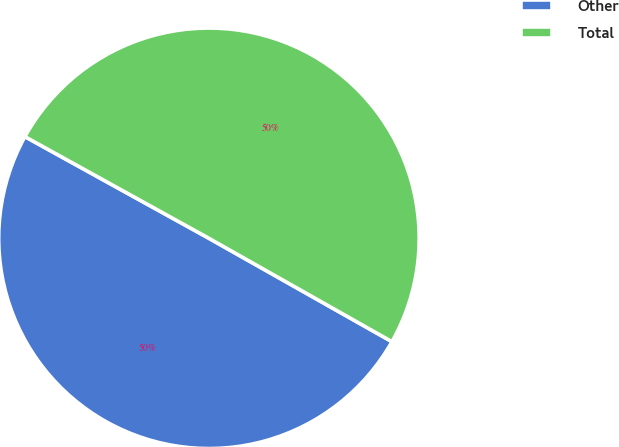<chart> <loc_0><loc_0><loc_500><loc_500><pie_chart><fcel>Other<fcel>Total<nl><fcel>49.85%<fcel>50.15%<nl></chart> 